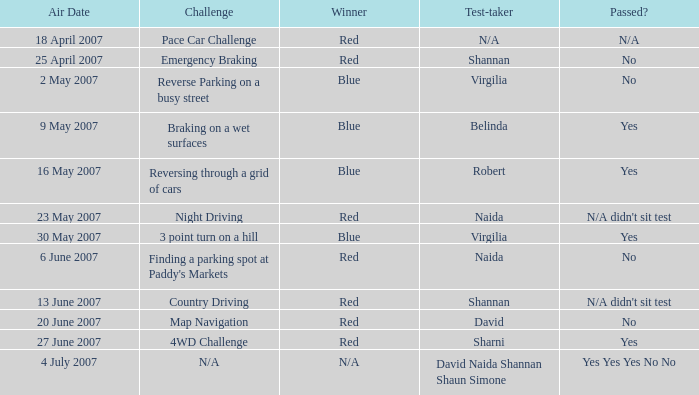What airing date includes a red winner and a crisis braking competition? 25 April 2007. 